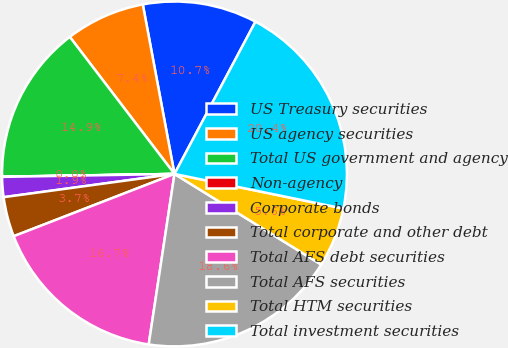Convert chart. <chart><loc_0><loc_0><loc_500><loc_500><pie_chart><fcel>US Treasury securities<fcel>US agency securities<fcel>Total US government and agency<fcel>Non-agency<fcel>Corporate bonds<fcel>Total corporate and other debt<fcel>Total AFS debt securities<fcel>Total AFS securities<fcel>Total HTM securities<fcel>Total investment securities<nl><fcel>10.72%<fcel>7.44%<fcel>14.87%<fcel>0.02%<fcel>1.88%<fcel>3.73%<fcel>16.73%<fcel>18.58%<fcel>5.59%<fcel>20.44%<nl></chart> 